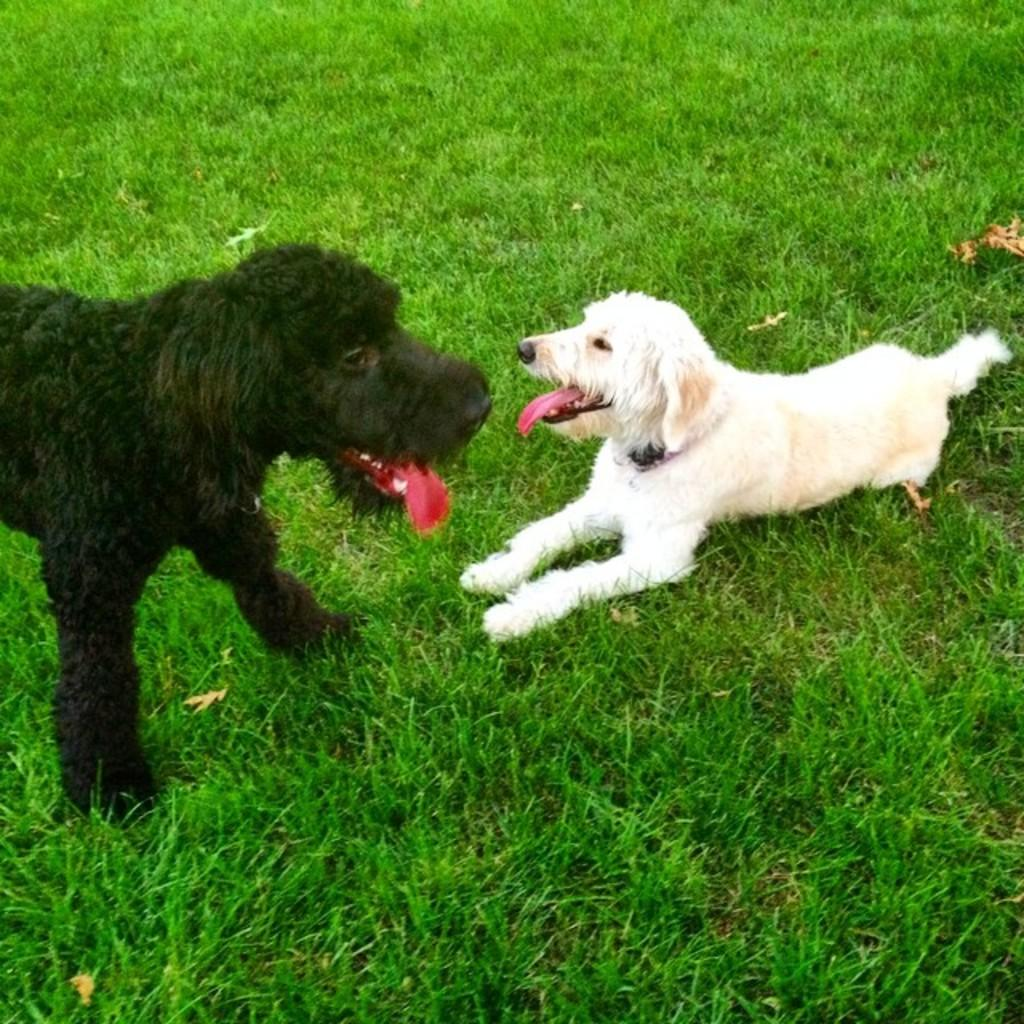What type of surface is at the bottom of the image? There is grass at the bottom of the image. What can be seen on the left side of the image? There is a black color dog on the left side of the image. What can be seen on the right side of the image? There is a white color dog on the right side of the image. What type of bird is flying over the dogs in the image? There is no bird present in the image; it only features two dogs and grass. 